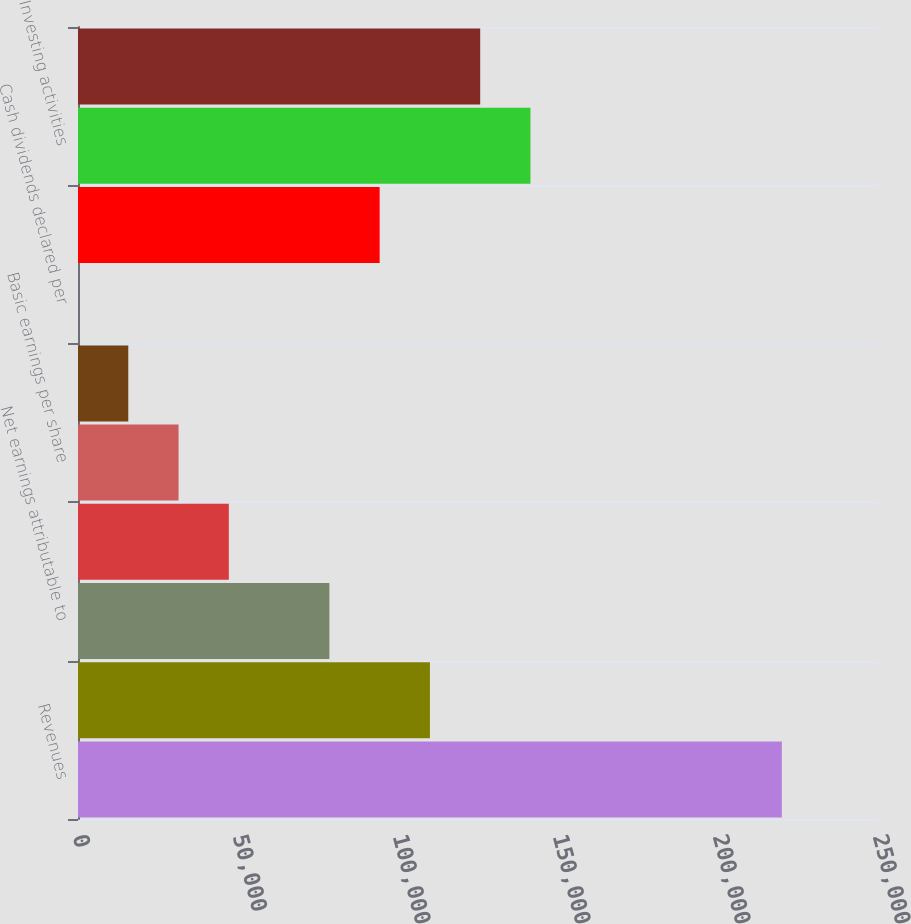<chart> <loc_0><loc_0><loc_500><loc_500><bar_chart><fcel>Revenues<fcel>Earnings from operations<fcel>Net earnings attributable to<fcel>Return on equity (b)<fcel>Basic earnings per share<fcel>Diluted earnings per share<fcel>Cash dividends declared per<fcel>Operating activities<fcel>Investing activities<fcel>Financing activities<nl><fcel>219949<fcel>109975<fcel>78554.4<fcel>47133.4<fcel>31422.9<fcel>15712.4<fcel>1.88<fcel>94264.9<fcel>141396<fcel>125686<nl></chart> 